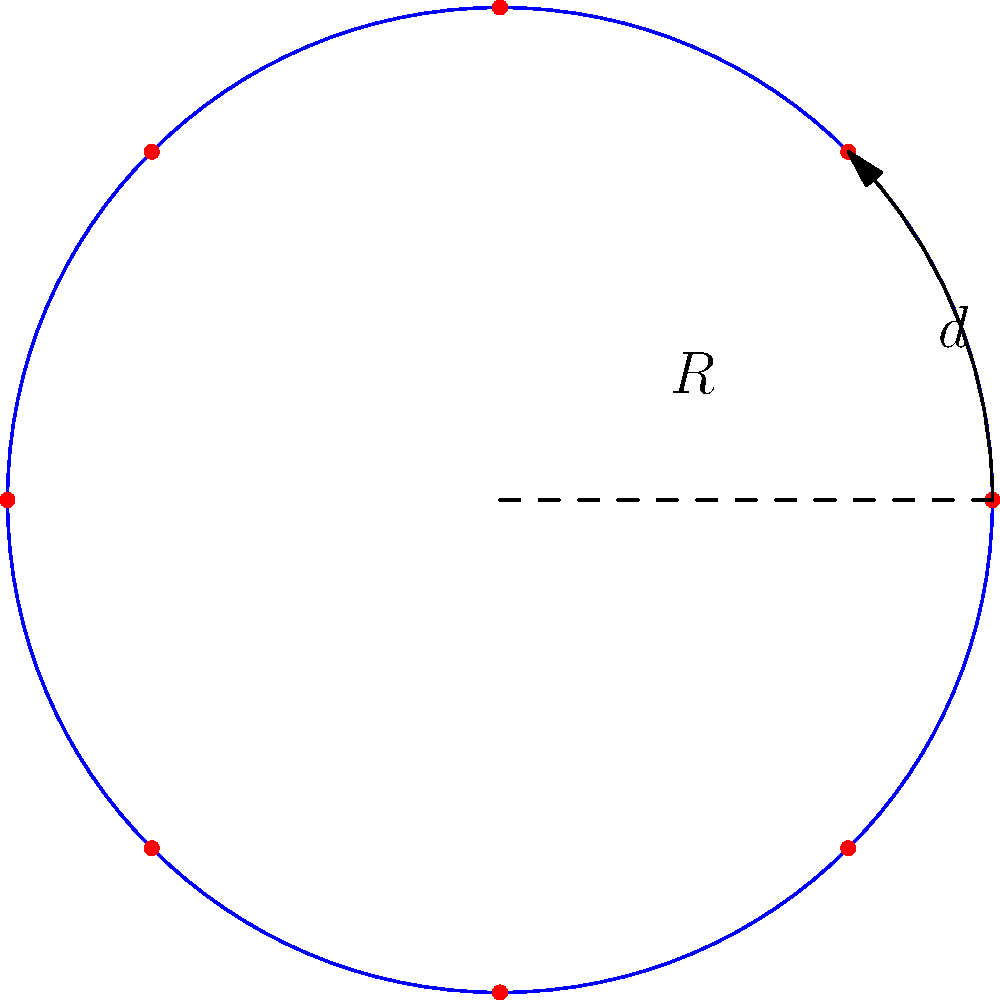As part of a project for a student club, you're designing a circular antenna array. The array consists of $8$ equally spaced elements, with a spacing of $3.8$ cm between adjacent elements. Calculate the radius of the circular array to the nearest tenth of a centimeter. Let's approach this step-by-step:

1) In a circular array with $n$ elements, the central angle between adjacent elements is $\frac{360°}{n} = \frac{2\pi}{n}$ radians.

2) In this case, $n = 8$, so the central angle is $\frac{2\pi}{8} = \frac{\pi}{4}$ radians.

3) The spacing between adjacent elements ($d$) forms a chord of this central angle in the circle.

4) The relationship between the radius ($R$), chord length ($d$), and central angle ($\theta$) is given by:

   $d = 2R \sin(\frac{\theta}{2})$

5) Substituting our values:

   $3.8 = 2R \sin(\frac{\pi}{8})$

6) Solving for $R$:

   $R = \frac{3.8}{2\sin(\frac{\pi}{8})}$

7) Calculate:
   $R \approx \frac{3.8}{2 \cdot 0.3827} \approx 4.96$ cm

8) Rounding to the nearest tenth:
   $R \approx 5.0$ cm
Answer: $5.0$ cm 